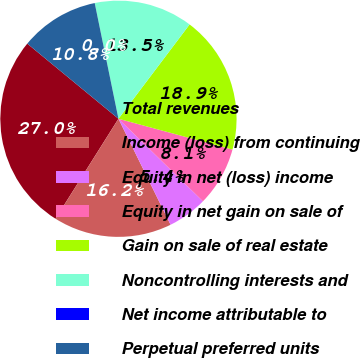Convert chart. <chart><loc_0><loc_0><loc_500><loc_500><pie_chart><fcel>Total revenues<fcel>Income (loss) from continuing<fcel>Equity in net (loss) income<fcel>Equity in net gain on sale of<fcel>Gain on sale of real estate<fcel>Noncontrolling interests and<fcel>Net income attributable to<fcel>Perpetual preferred units<nl><fcel>27.03%<fcel>16.22%<fcel>5.41%<fcel>8.11%<fcel>18.92%<fcel>13.51%<fcel>0.0%<fcel>10.81%<nl></chart> 